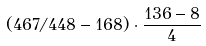Convert formula to latex. <formula><loc_0><loc_0><loc_500><loc_500>( 4 6 7 / 4 4 8 - 1 6 8 ) \cdot \frac { 1 3 6 - 8 } { 4 }</formula> 